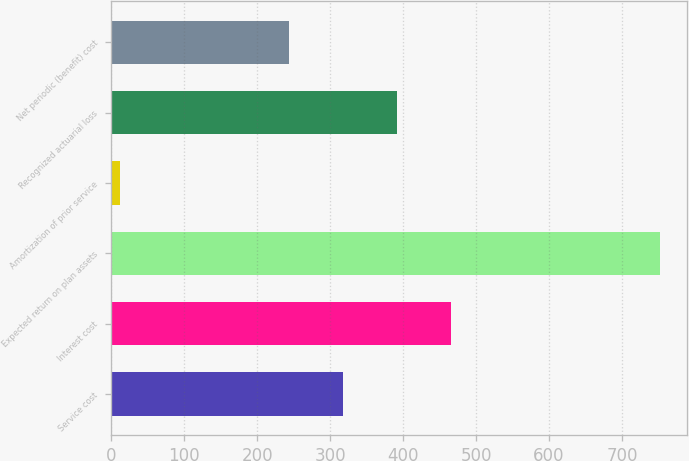Convert chart. <chart><loc_0><loc_0><loc_500><loc_500><bar_chart><fcel>Service cost<fcel>Interest cost<fcel>Expected return on plan assets<fcel>Amortization of prior service<fcel>Recognized actuarial loss<fcel>Net periodic (benefit) cost<nl><fcel>317.83<fcel>465.89<fcel>752.1<fcel>11.8<fcel>391.86<fcel>243.8<nl></chart> 